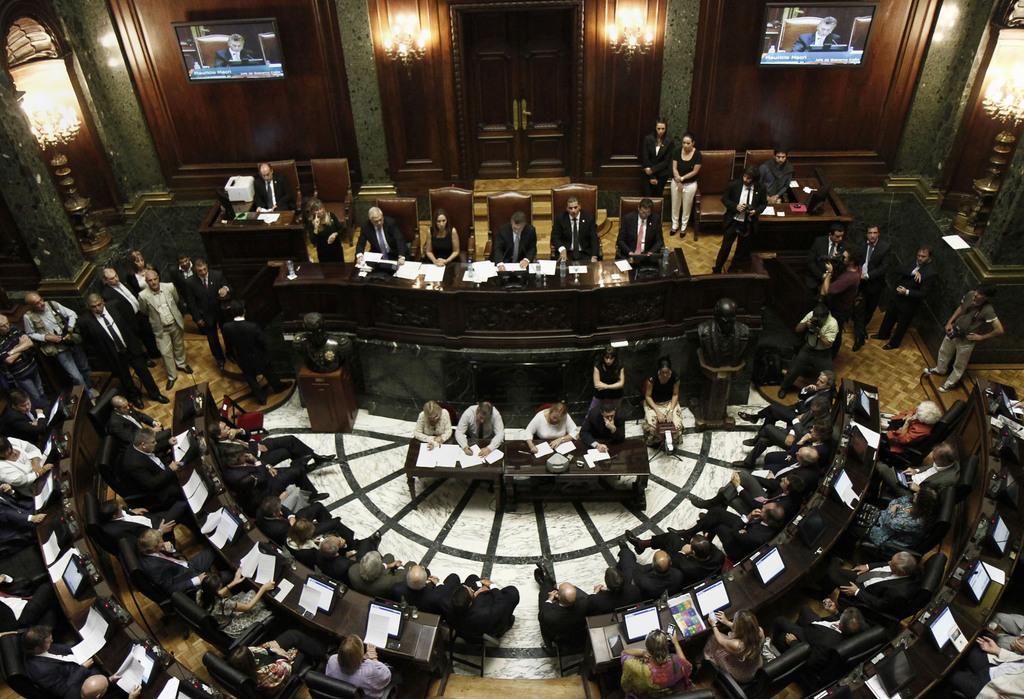Please provide a concise description of this image. In this image I can see there are group of persons sitting on the chairs and in front of them I can see a table , on the table I can see papers and sum of them standing on the floor in the middle at the top I can see screens attached to the wooden wall 